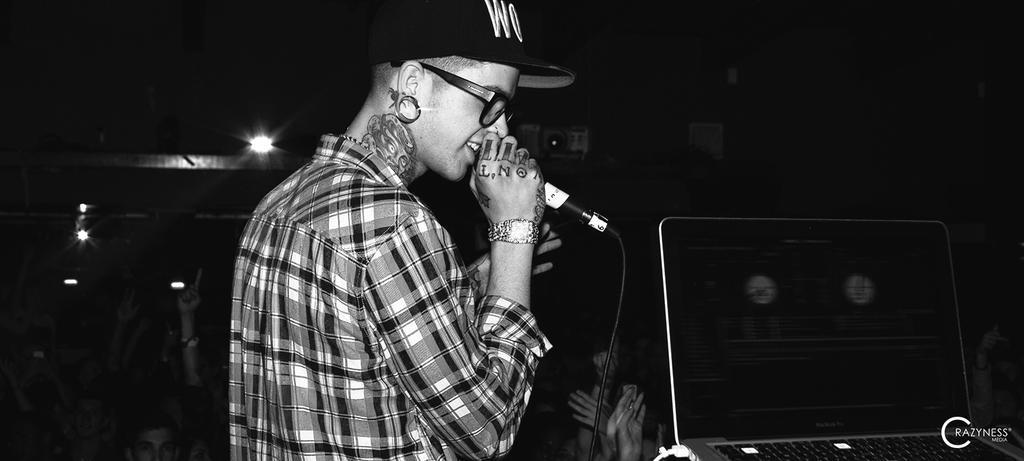Describe this image in one or two sentences. In this image i can see a holding a mike on her hand and she wearing a spectacles and black color cap. on the right side i can see a lights visible. 